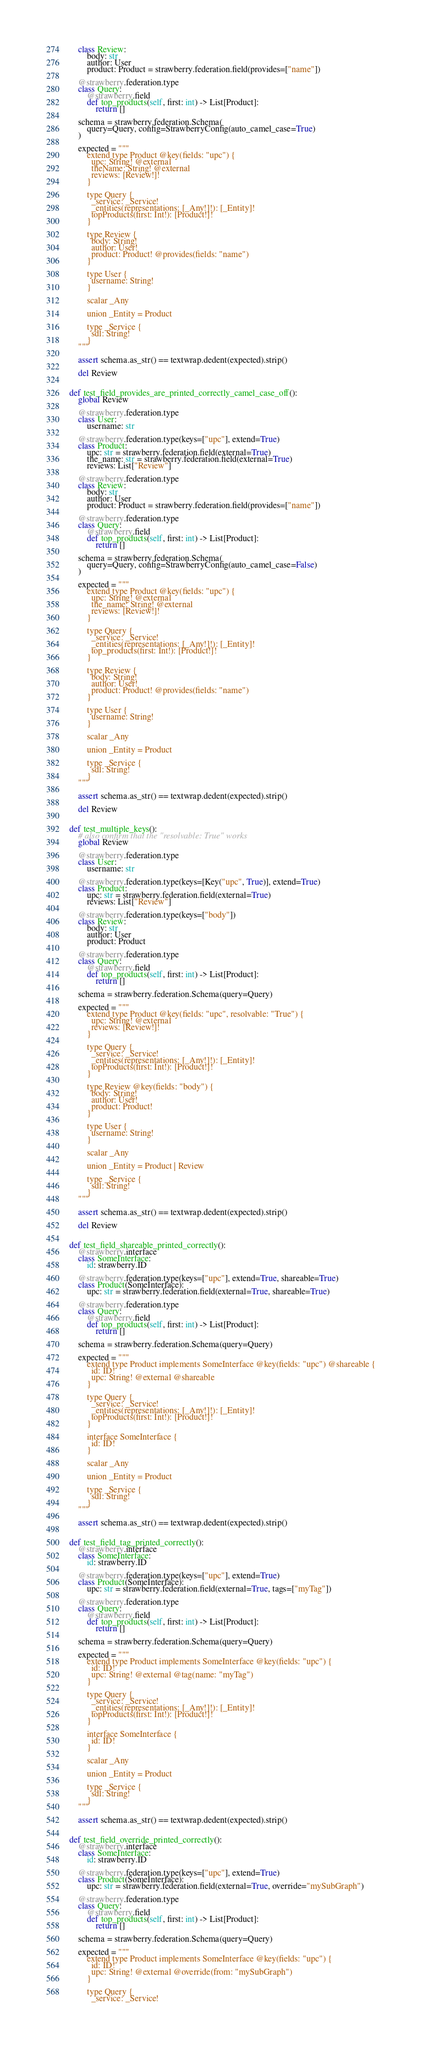Convert code to text. <code><loc_0><loc_0><loc_500><loc_500><_Python_>    class Review:
        body: str
        author: User
        product: Product = strawberry.federation.field(provides=["name"])

    @strawberry.federation.type
    class Query:
        @strawberry.field
        def top_products(self, first: int) -> List[Product]:
            return []

    schema = strawberry.federation.Schema(
        query=Query, config=StrawberryConfig(auto_camel_case=True)
    )

    expected = """
        extend type Product @key(fields: "upc") {
          upc: String! @external
          theName: String! @external
          reviews: [Review!]!
        }

        type Query {
          _service: _Service!
          _entities(representations: [_Any!]!): [_Entity]!
          topProducts(first: Int!): [Product!]!
        }

        type Review {
          body: String!
          author: User!
          product: Product! @provides(fields: "name")
        }

        type User {
          username: String!
        }

        scalar _Any

        union _Entity = Product

        type _Service {
          sdl: String!
        }
    """

    assert schema.as_str() == textwrap.dedent(expected).strip()

    del Review


def test_field_provides_are_printed_correctly_camel_case_off():
    global Review

    @strawberry.federation.type
    class User:
        username: str

    @strawberry.federation.type(keys=["upc"], extend=True)
    class Product:
        upc: str = strawberry.federation.field(external=True)
        the_name: str = strawberry.federation.field(external=True)
        reviews: List["Review"]

    @strawberry.federation.type
    class Review:
        body: str
        author: User
        product: Product = strawberry.federation.field(provides=["name"])

    @strawberry.federation.type
    class Query:
        @strawberry.field
        def top_products(self, first: int) -> List[Product]:
            return []

    schema = strawberry.federation.Schema(
        query=Query, config=StrawberryConfig(auto_camel_case=False)
    )

    expected = """
        extend type Product @key(fields: "upc") {
          upc: String! @external
          the_name: String! @external
          reviews: [Review!]!
        }

        type Query {
          _service: _Service!
          _entities(representations: [_Any!]!): [_Entity]!
          top_products(first: Int!): [Product!]!
        }

        type Review {
          body: String!
          author: User!
          product: Product! @provides(fields: "name")
        }

        type User {
          username: String!
        }

        scalar _Any

        union _Entity = Product

        type _Service {
          sdl: String!
        }
    """

    assert schema.as_str() == textwrap.dedent(expected).strip()

    del Review


def test_multiple_keys():
    # also confirm that the "resolvable: True" works
    global Review

    @strawberry.federation.type
    class User:
        username: str

    @strawberry.federation.type(keys=[Key("upc", True)], extend=True)
    class Product:
        upc: str = strawberry.federation.field(external=True)
        reviews: List["Review"]

    @strawberry.federation.type(keys=["body"])
    class Review:
        body: str
        author: User
        product: Product

    @strawberry.federation.type
    class Query:
        @strawberry.field
        def top_products(self, first: int) -> List[Product]:
            return []

    schema = strawberry.federation.Schema(query=Query)

    expected = """
        extend type Product @key(fields: "upc", resolvable: "True") {
          upc: String! @external
          reviews: [Review!]!
        }

        type Query {
          _service: _Service!
          _entities(representations: [_Any!]!): [_Entity]!
          topProducts(first: Int!): [Product!]!
        }

        type Review @key(fields: "body") {
          body: String!
          author: User!
          product: Product!
        }

        type User {
          username: String!
        }

        scalar _Any

        union _Entity = Product | Review

        type _Service {
          sdl: String!
        }
    """

    assert schema.as_str() == textwrap.dedent(expected).strip()

    del Review


def test_field_shareable_printed_correctly():
    @strawberry.interface
    class SomeInterface:
        id: strawberry.ID

    @strawberry.federation.type(keys=["upc"], extend=True, shareable=True)
    class Product(SomeInterface):
        upc: str = strawberry.federation.field(external=True, shareable=True)

    @strawberry.federation.type
    class Query:
        @strawberry.field
        def top_products(self, first: int) -> List[Product]:
            return []

    schema = strawberry.federation.Schema(query=Query)

    expected = """
        extend type Product implements SomeInterface @key(fields: "upc") @shareable {
          id: ID!
          upc: String! @external @shareable
        }

        type Query {
          _service: _Service!
          _entities(representations: [_Any!]!): [_Entity]!
          topProducts(first: Int!): [Product!]!
        }

        interface SomeInterface {
          id: ID!
        }

        scalar _Any

        union _Entity = Product

        type _Service {
          sdl: String!
        }
    """

    assert schema.as_str() == textwrap.dedent(expected).strip()


def test_field_tag_printed_correctly():
    @strawberry.interface
    class SomeInterface:
        id: strawberry.ID

    @strawberry.federation.type(keys=["upc"], extend=True)
    class Product(SomeInterface):
        upc: str = strawberry.federation.field(external=True, tags=["myTag"])

    @strawberry.federation.type
    class Query:
        @strawberry.field
        def top_products(self, first: int) -> List[Product]:
            return []

    schema = strawberry.federation.Schema(query=Query)

    expected = """
        extend type Product implements SomeInterface @key(fields: "upc") {
          id: ID!
          upc: String! @external @tag(name: "myTag")
        }

        type Query {
          _service: _Service!
          _entities(representations: [_Any!]!): [_Entity]!
          topProducts(first: Int!): [Product!]!
        }

        interface SomeInterface {
          id: ID!
        }

        scalar _Any

        union _Entity = Product

        type _Service {
          sdl: String!
        }
    """

    assert schema.as_str() == textwrap.dedent(expected).strip()


def test_field_override_printed_correctly():
    @strawberry.interface
    class SomeInterface:
        id: strawberry.ID

    @strawberry.federation.type(keys=["upc"], extend=True)
    class Product(SomeInterface):
        upc: str = strawberry.federation.field(external=True, override="mySubGraph")

    @strawberry.federation.type
    class Query:
        @strawberry.field
        def top_products(self, first: int) -> List[Product]:
            return []

    schema = strawberry.federation.Schema(query=Query)

    expected = """
        extend type Product implements SomeInterface @key(fields: "upc") {
          id: ID!
          upc: String! @external @override(from: "mySubGraph")
        }

        type Query {
          _service: _Service!</code> 